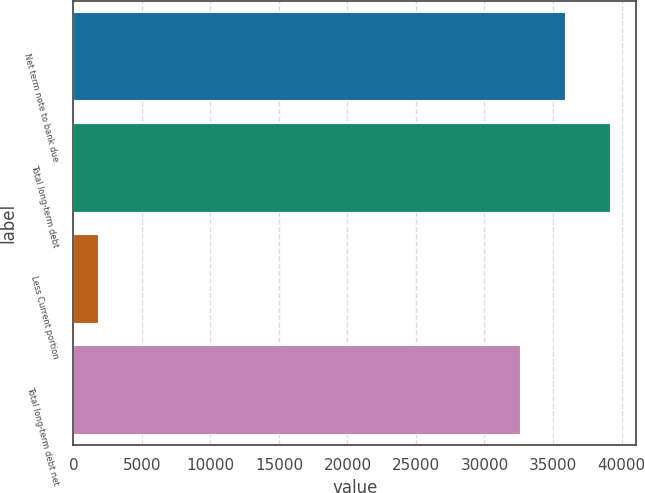Convert chart to OTSL. <chart><loc_0><loc_0><loc_500><loc_500><bar_chart><fcel>Net term note to bank due<fcel>Total long-term debt<fcel>Less Current portion<fcel>Total long-term debt net<nl><fcel>35875.4<fcel>39136.8<fcel>1775<fcel>32614<nl></chart> 